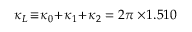<formula> <loc_0><loc_0><loc_500><loc_500>\kappa _ { L } \, \equiv \, \kappa _ { 0 } \, + \, \kappa _ { 1 } \, + \, \kappa _ { 2 } = 2 \pi \times \, 1 . 5 1 0</formula> 